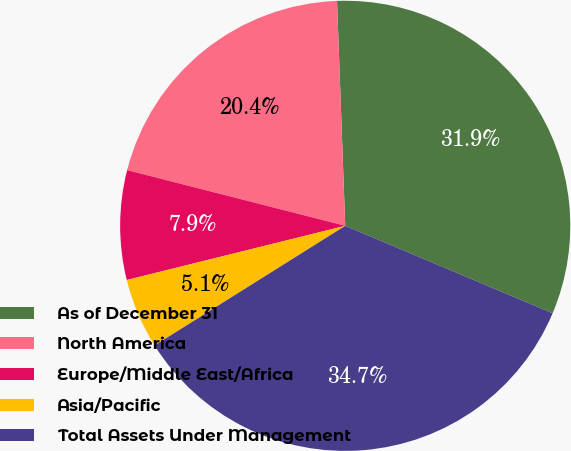Convert chart. <chart><loc_0><loc_0><loc_500><loc_500><pie_chart><fcel>As of December 31<fcel>North America<fcel>Europe/Middle East/Africa<fcel>Asia/Pacific<fcel>Total Assets Under Management<nl><fcel>31.93%<fcel>20.44%<fcel>7.85%<fcel>5.05%<fcel>34.73%<nl></chart> 